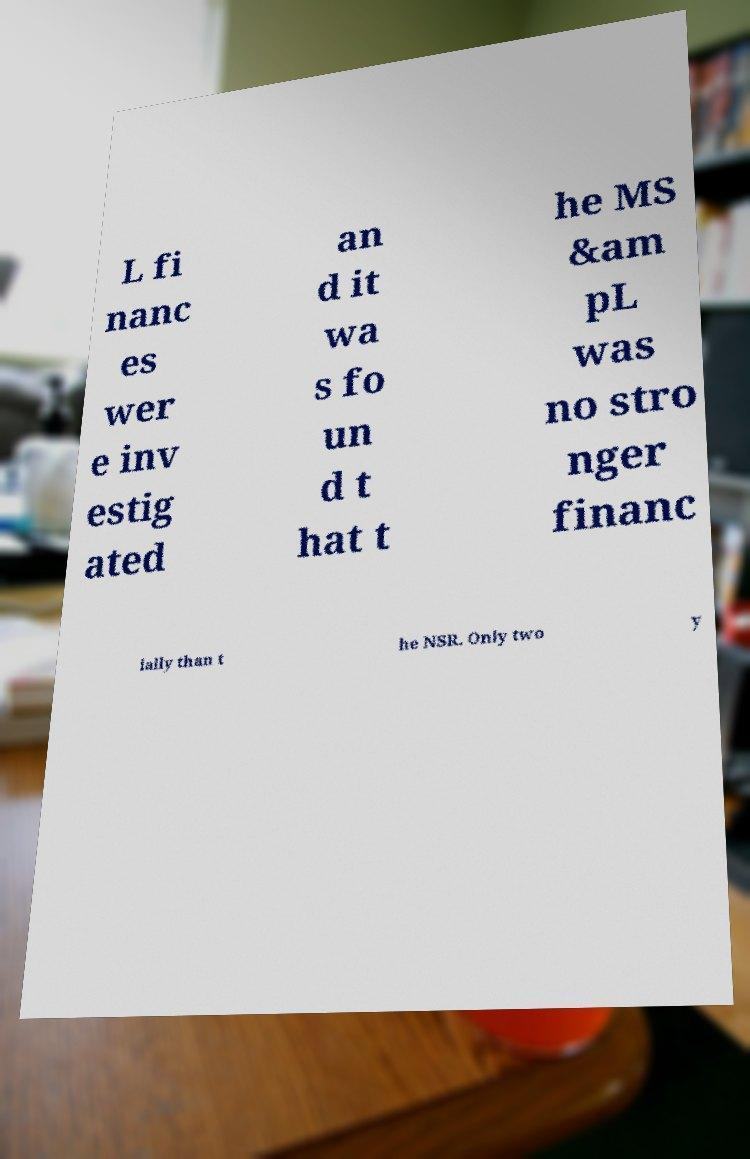For documentation purposes, I need the text within this image transcribed. Could you provide that? L fi nanc es wer e inv estig ated an d it wa s fo un d t hat t he MS &am pL was no stro nger financ ially than t he NSR. Only two y 